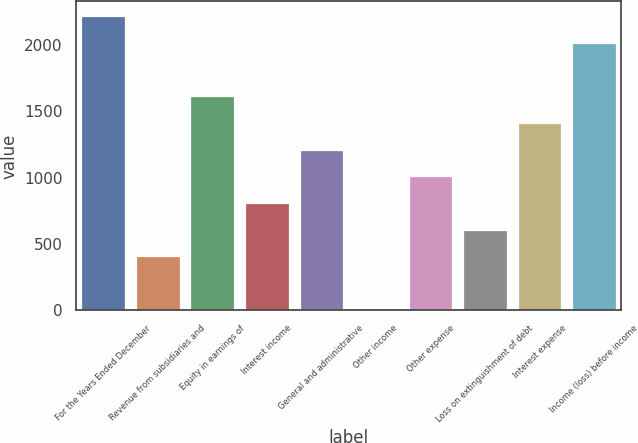Convert chart to OTSL. <chart><loc_0><loc_0><loc_500><loc_500><bar_chart><fcel>For the Years Ended December<fcel>Revenue from subsidiaries and<fcel>Equity in earnings of<fcel>Interest income<fcel>General and administrative<fcel>Other income<fcel>Other expense<fcel>Loss on extinguishment of debt<fcel>Interest expense<fcel>Income (loss) before income<nl><fcel>2216.9<fcel>408.8<fcel>1614.2<fcel>810.6<fcel>1212.4<fcel>7<fcel>1011.5<fcel>609.7<fcel>1413.3<fcel>2016<nl></chart> 